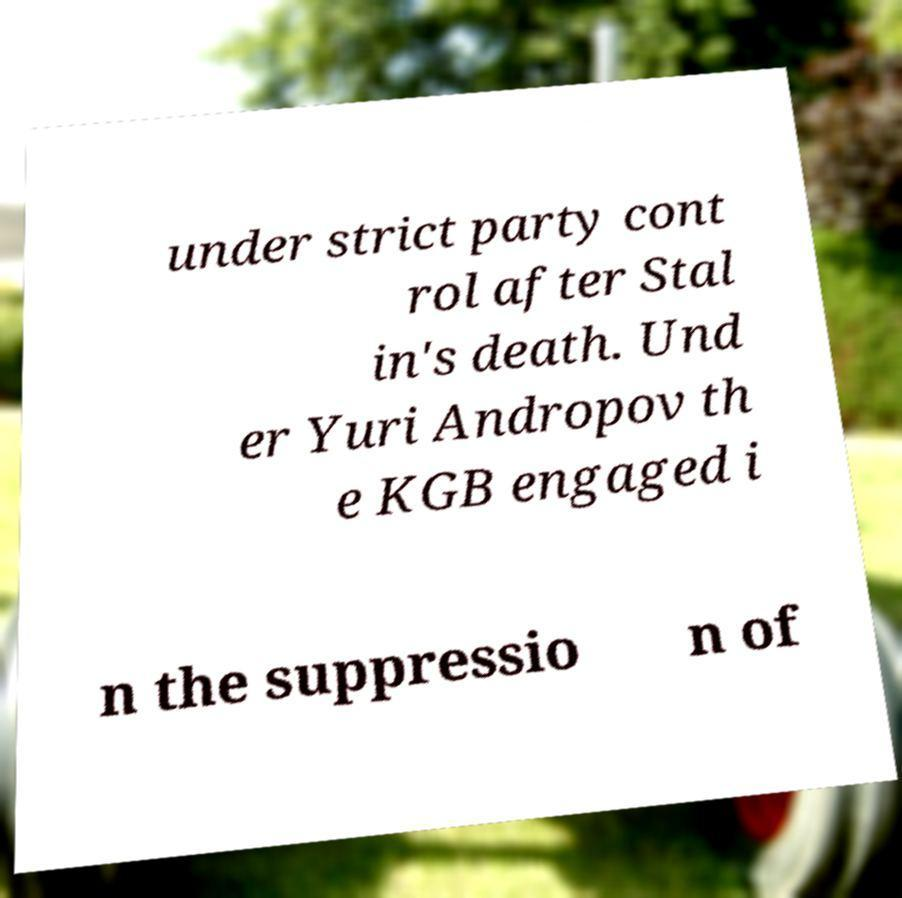Could you assist in decoding the text presented in this image and type it out clearly? under strict party cont rol after Stal in's death. Und er Yuri Andropov th e KGB engaged i n the suppressio n of 